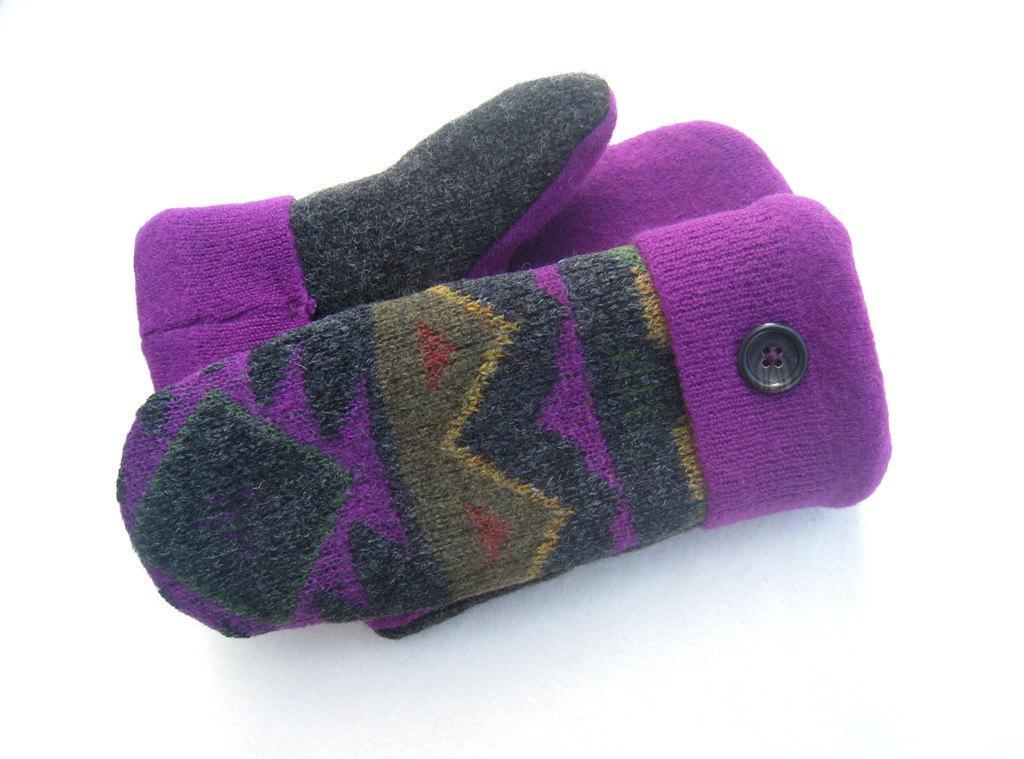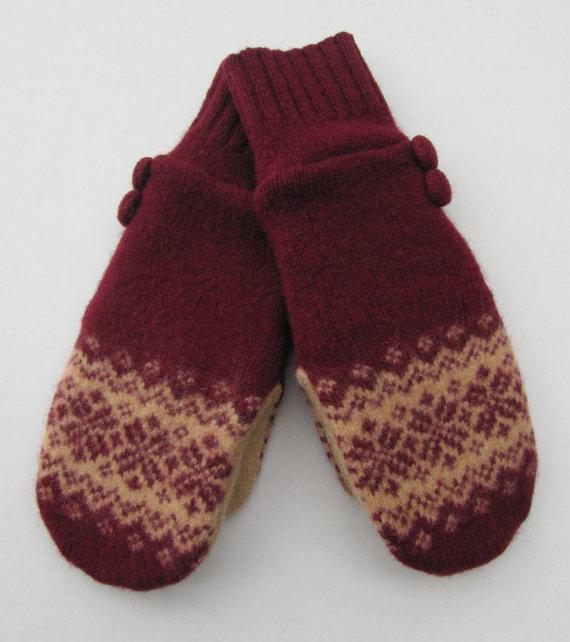The first image is the image on the left, the second image is the image on the right. Evaluate the accuracy of this statement regarding the images: "Two pairs of traditional mittens are shown, with the fingers covered by one rounded section.". Is it true? Answer yes or no. Yes. The first image is the image on the left, the second image is the image on the right. Examine the images to the left and right. Is the description "One of the glove sets has an embitt" accurate? Answer yes or no. No. 